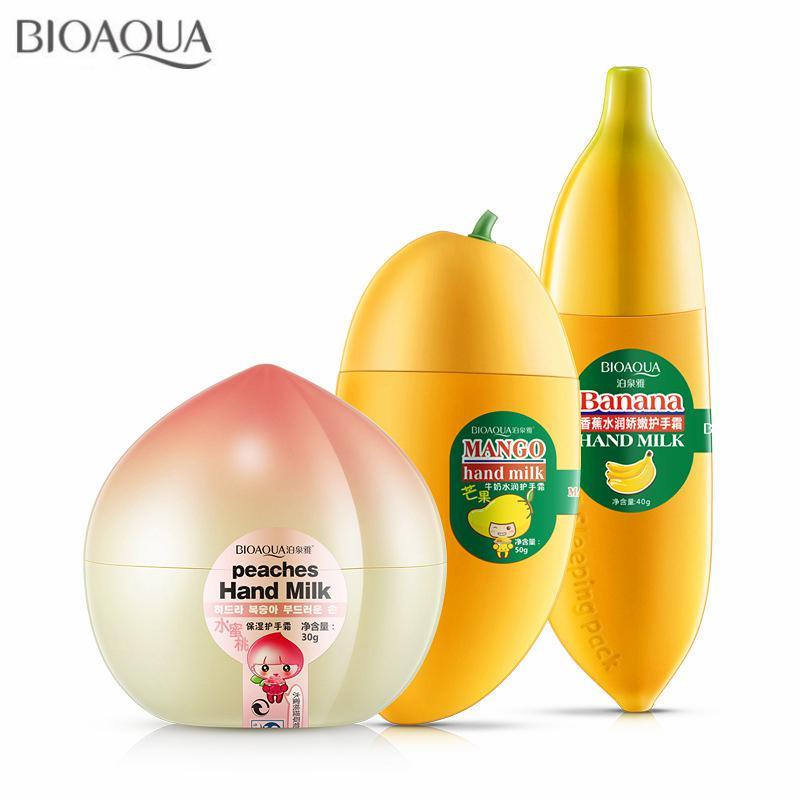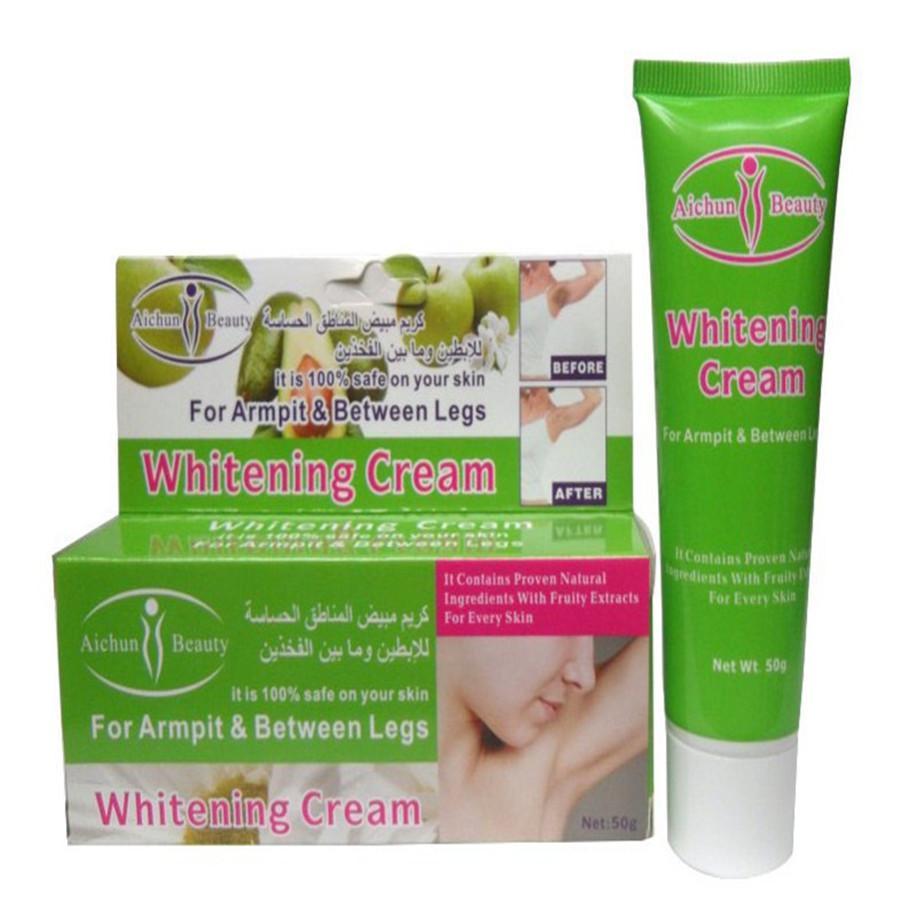The first image is the image on the left, the second image is the image on the right. Analyze the images presented: Is the assertion "A box and a tube of whitening cream are in one image." valid? Answer yes or no. Yes. 